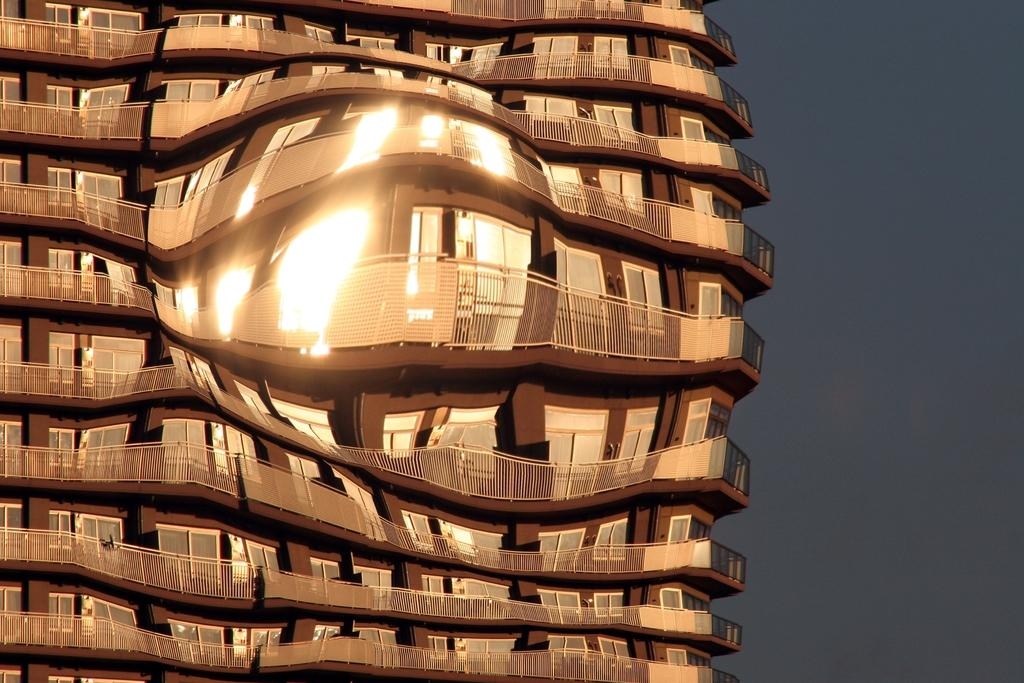What is the main subject of the image? The main subject of the image is a building. Can you describe the colors of the building? The building is brown and cream in color. What can be seen in the background of the image? The sky is visible in the background of the image. How many cherries are on top of the building in the image? There are no cherries present in the image; the building is brown and cream in color. What arithmetic problem is being solved on the side of the building? There is no arithmetic problem visible on the building in the image. 